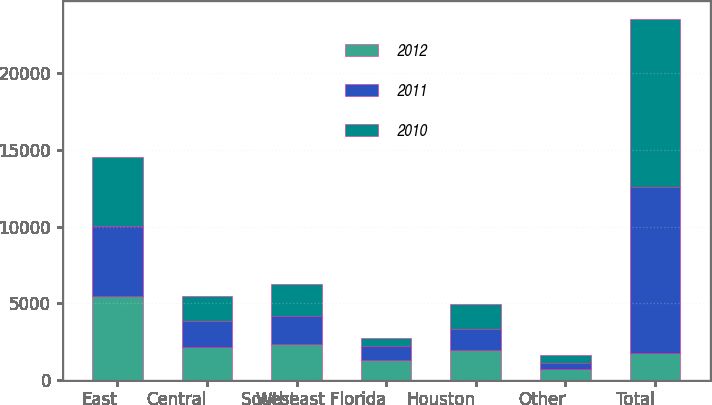<chart> <loc_0><loc_0><loc_500><loc_500><stacked_bar_chart><ecel><fcel>East<fcel>Central<fcel>West<fcel>Southeast Florida<fcel>Houston<fcel>Other<fcel>Total<nl><fcel>2012<fcel>5440<fcel>2154<fcel>2301<fcel>1314<fcel>1917<fcel>676<fcel>1764<nl><fcel>2011<fcel>4576<fcel>1661<fcel>1846<fcel>904<fcel>1411<fcel>447<fcel>10845<nl><fcel>2010<fcel>4539<fcel>1682<fcel>2079<fcel>536<fcel>1645<fcel>474<fcel>10955<nl></chart> 